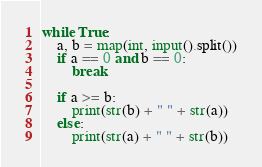<code> <loc_0><loc_0><loc_500><loc_500><_Python_>while True:
    a, b = map(int, input().split())
    if a == 0 and b == 0:
        break
    
    if a >= b:
        print(str(b) + " " + str(a))
    else:
        print(str(a) + " " + str(b))
</code> 